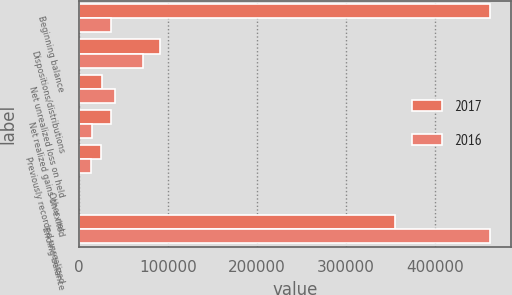Convert chart to OTSL. <chart><loc_0><loc_0><loc_500><loc_500><stacked_bar_chart><ecel><fcel>Beginning balance<fcel>Dispositions/distributions<fcel>Net unrealized loss on held<fcel>Net realized gains on exited<fcel>Previously recorded unrealized<fcel>Other net<fcel>Ending balance<nl><fcel>2017<fcel>462132<fcel>91606<fcel>25807<fcel>36078<fcel>25538<fcel>455<fcel>354804<nl><fcel>2016<fcel>36078<fcel>71888<fcel>41162<fcel>14761<fcel>14254<fcel>86<fcel>462132<nl></chart> 